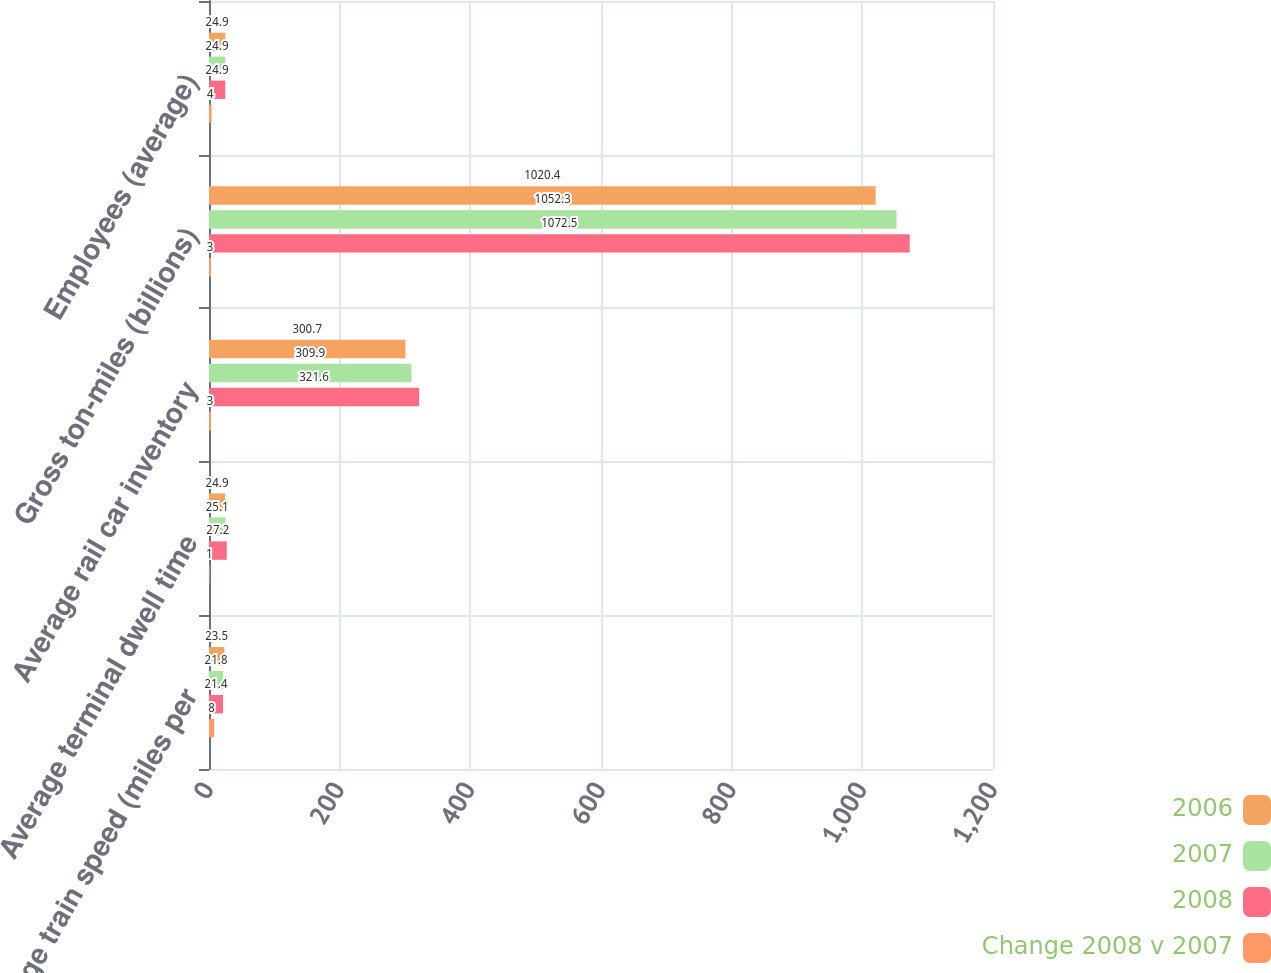<chart> <loc_0><loc_0><loc_500><loc_500><stacked_bar_chart><ecel><fcel>Average train speed (miles per<fcel>Average terminal dwell time<fcel>Average rail car inventory<fcel>Gross ton-miles (billions)<fcel>Employees (average)<nl><fcel>2006<fcel>23.5<fcel>24.9<fcel>300.7<fcel>1020.4<fcel>24.9<nl><fcel>2007<fcel>21.8<fcel>25.1<fcel>309.9<fcel>1052.3<fcel>24.9<nl><fcel>2008<fcel>21.4<fcel>27.2<fcel>321.6<fcel>1072.5<fcel>24.9<nl><fcel>Change 2008 v 2007<fcel>8<fcel>1<fcel>3<fcel>3<fcel>4<nl></chart> 